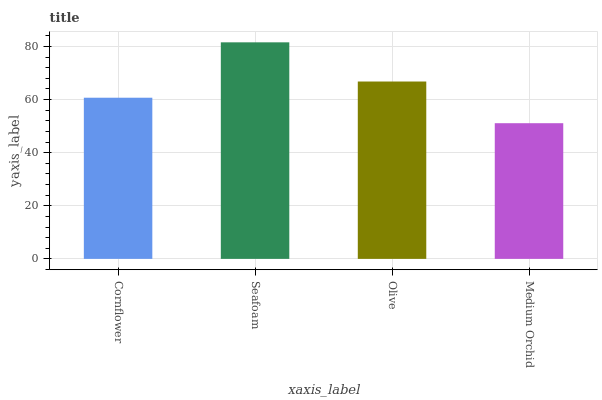Is Medium Orchid the minimum?
Answer yes or no. Yes. Is Seafoam the maximum?
Answer yes or no. Yes. Is Olive the minimum?
Answer yes or no. No. Is Olive the maximum?
Answer yes or no. No. Is Seafoam greater than Olive?
Answer yes or no. Yes. Is Olive less than Seafoam?
Answer yes or no. Yes. Is Olive greater than Seafoam?
Answer yes or no. No. Is Seafoam less than Olive?
Answer yes or no. No. Is Olive the high median?
Answer yes or no. Yes. Is Cornflower the low median?
Answer yes or no. Yes. Is Cornflower the high median?
Answer yes or no. No. Is Seafoam the low median?
Answer yes or no. No. 